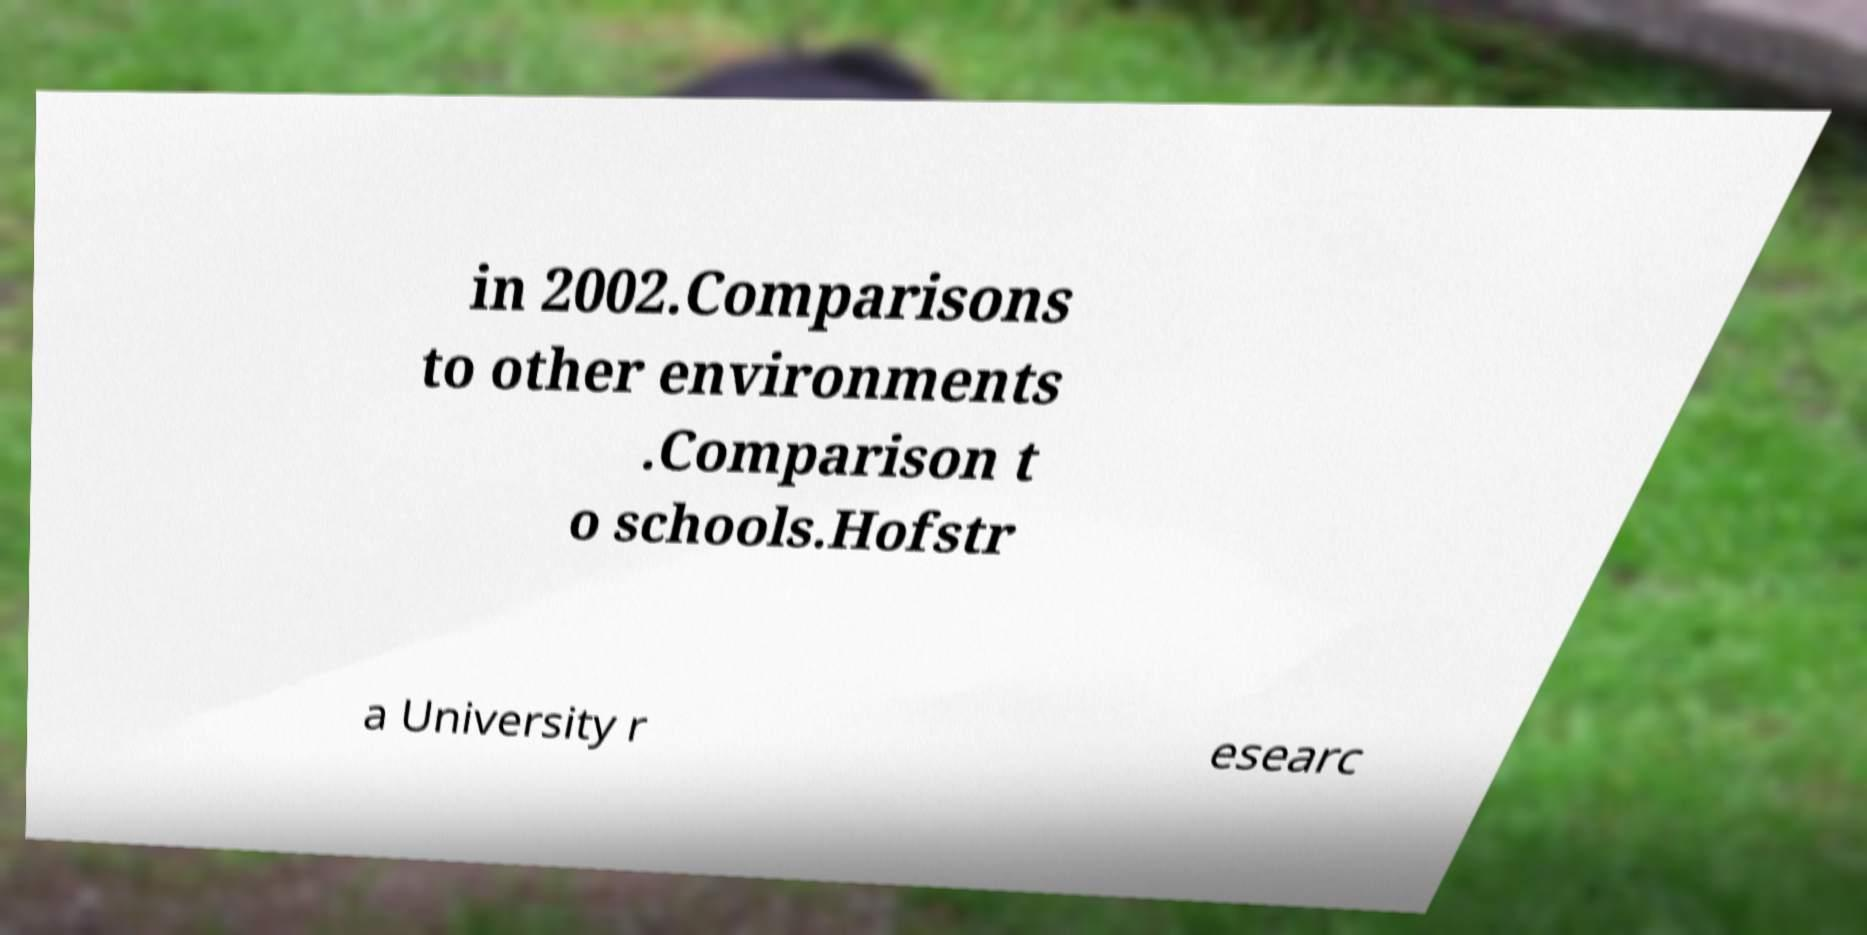For documentation purposes, I need the text within this image transcribed. Could you provide that? in 2002.Comparisons to other environments .Comparison t o schools.Hofstr a University r esearc 